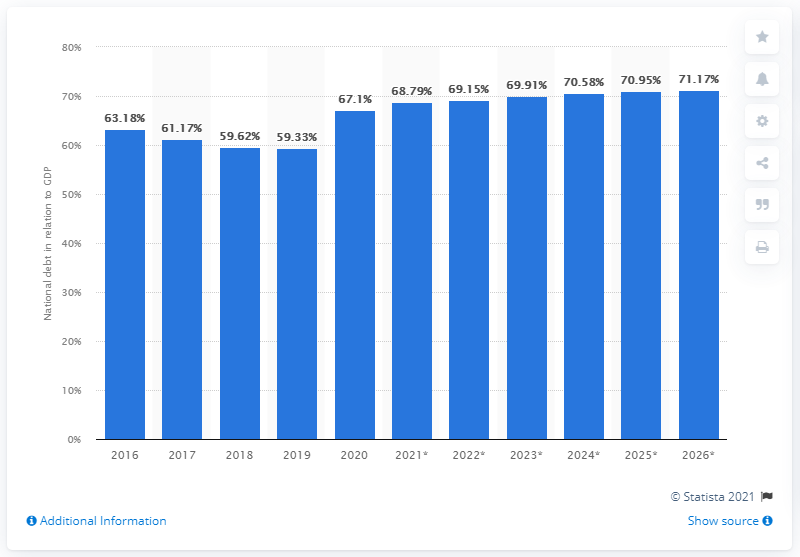Indicate a few pertinent items in this graphic. As of 2020, the national debt of Finland accounted for approximately 67.1% of the country's Gross Domestic Product (GDP). 